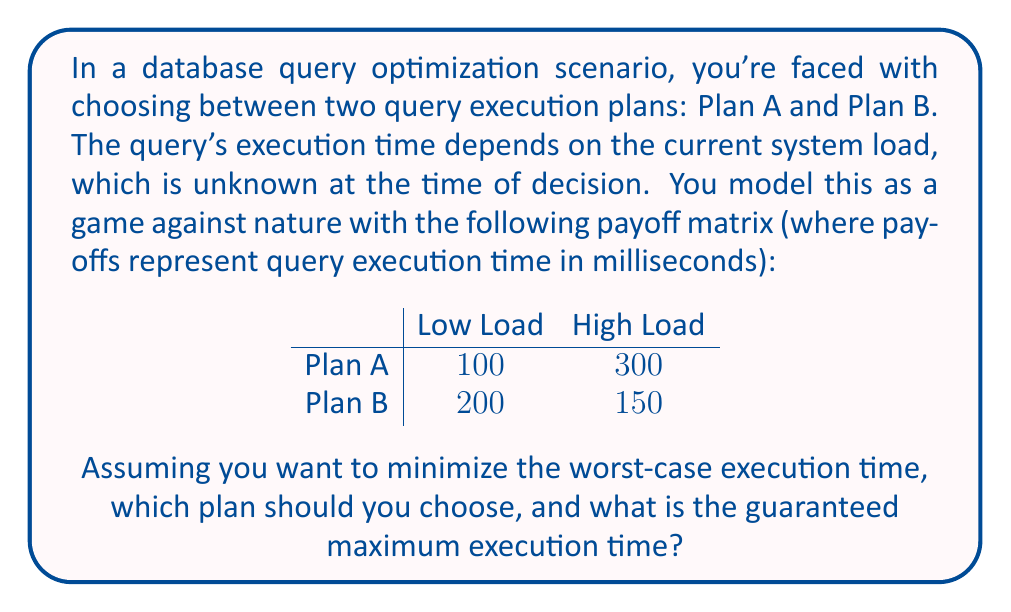Give your solution to this math problem. To solve this problem, we'll use the minimax decision rule, which is appropriate for games against nature where we want to minimize the worst-case scenario.

Step 1: Identify the worst-case scenario for each plan.
- For Plan A: $\max(100, 300) = 300$ ms
- For Plan B: $\max(200, 150) = 200$ ms

Step 2: Choose the plan with the minimum worst-case scenario.
$\min(300, 200) = 200$ ms, which corresponds to Plan B.

By choosing Plan B, we guarantee that the query execution time will not exceed 200 ms, regardless of the system load.

This approach aligns with the "minimax" strategy in game theory, where we minimize the maximum possible loss. In database query optimization, this strategy can be particularly useful when we want to ensure consistent performance and avoid exceptionally long query execution times.
Answer: Choose Plan B, with a guaranteed maximum execution time of 200 ms. 